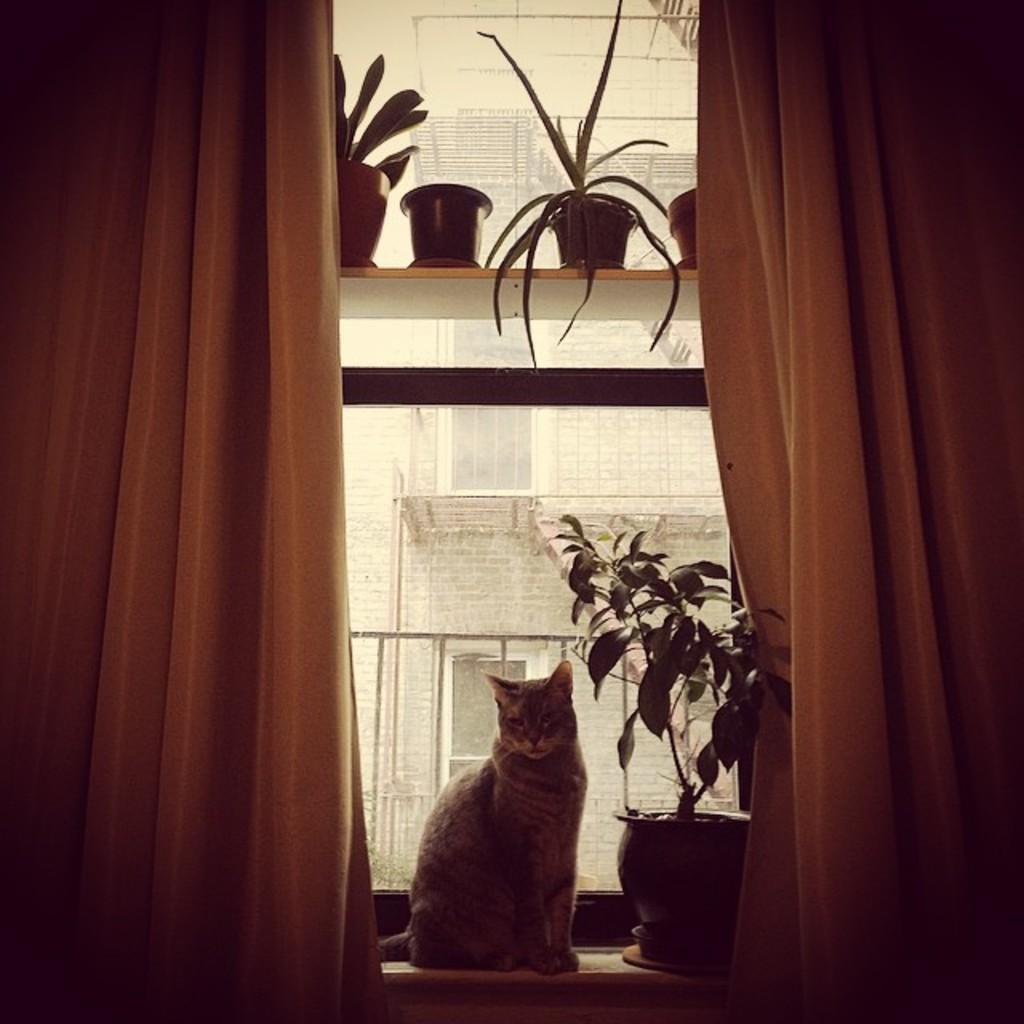What animal is sitting on the window in the image? There is a cat sitting on the window in the image. What else can be seen in the image besides the cat? There are plants in the image. What type of window treatment is present in the image? There are curtains on either side of the window in the image. Where is the seed stored in the image? There is no seed present in the image. What type of mine is visible in the image? There is no mine present in the image. 